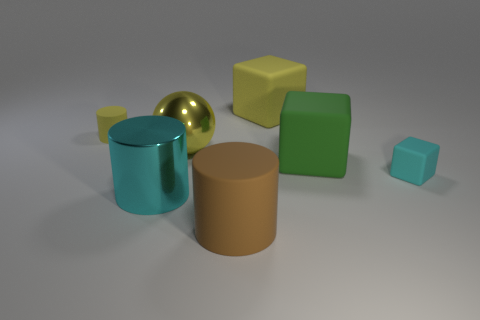Add 1 cyan matte balls. How many objects exist? 8 Subtract all cylinders. How many objects are left? 4 Add 6 tiny cyan cubes. How many tiny cyan cubes exist? 7 Subtract 0 gray cubes. How many objects are left? 7 Subtract all cyan metallic cylinders. Subtract all large green objects. How many objects are left? 5 Add 2 big yellow matte things. How many big yellow matte things are left? 3 